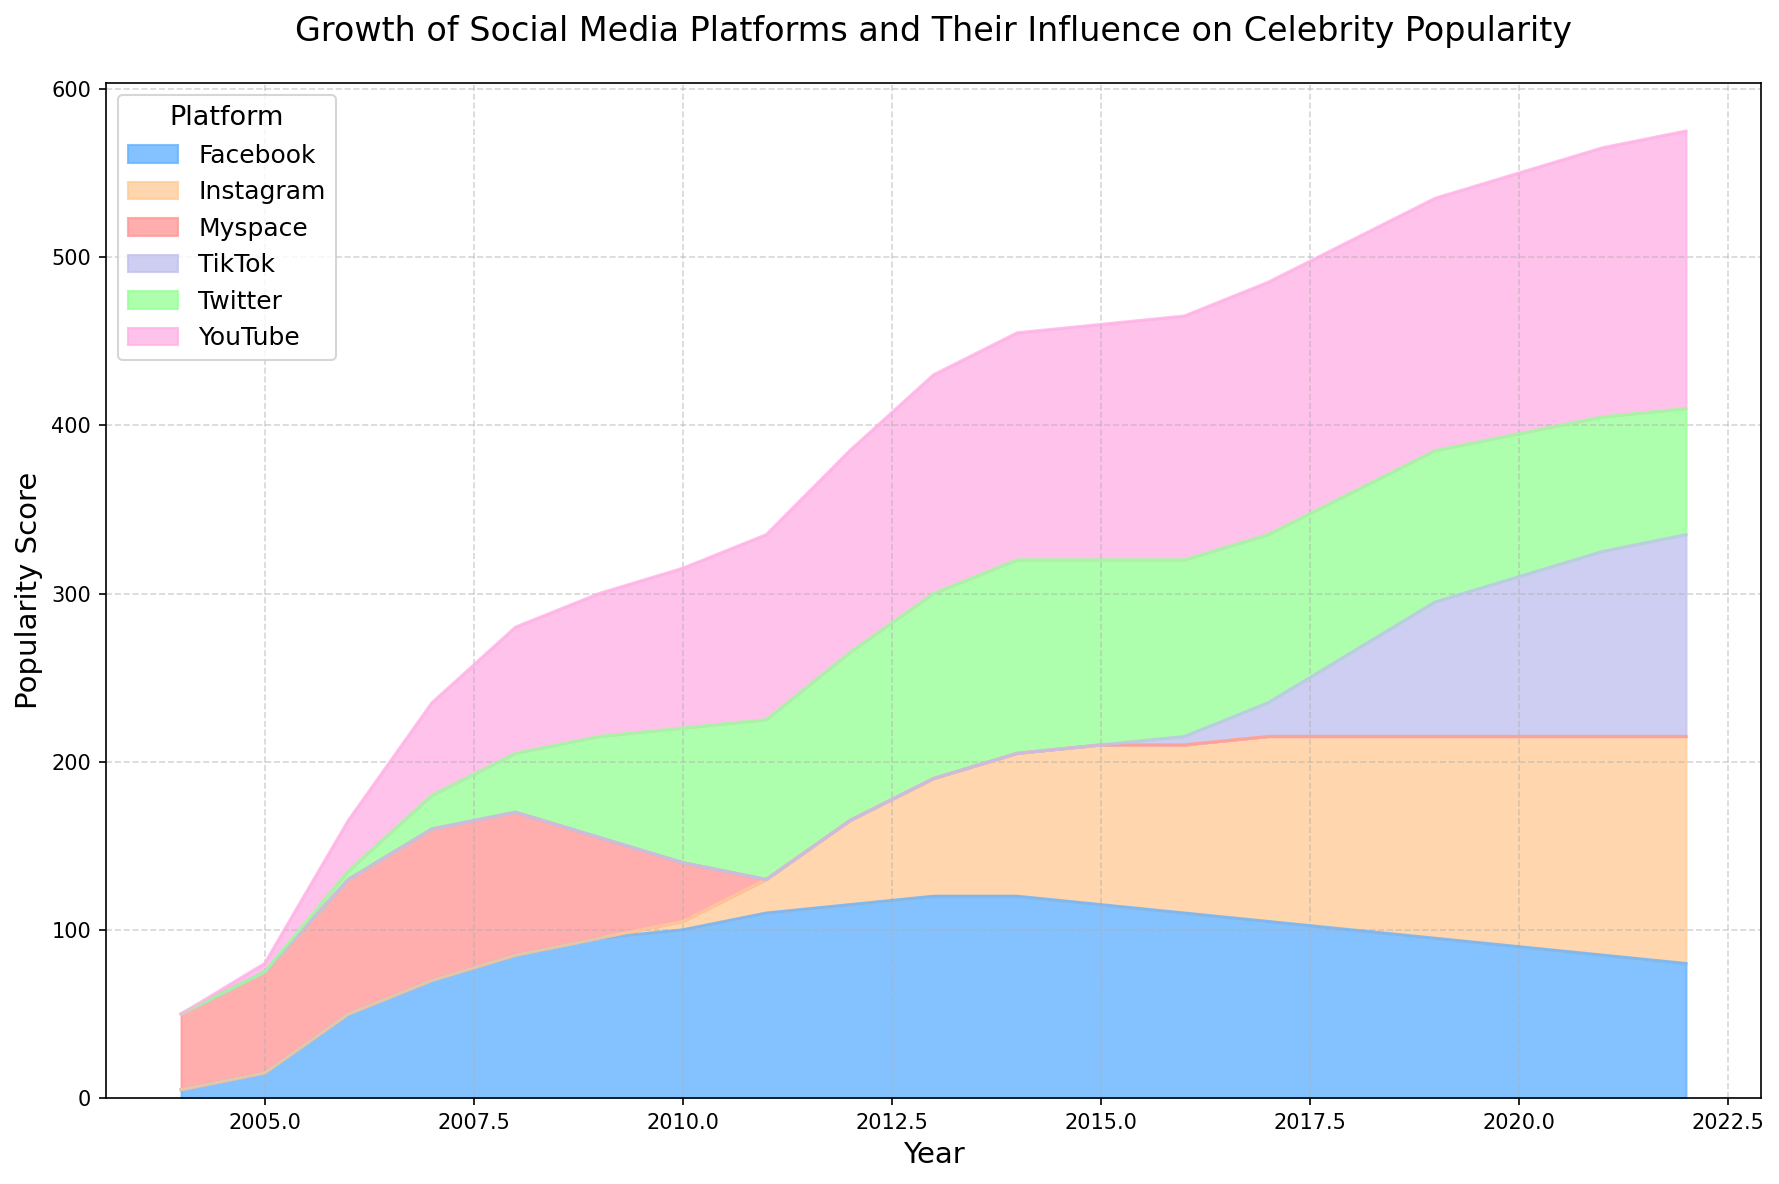What is the total popularity score for Instagram and Twitter in 2022? First, locate the year 2022 on the x-axis and identify the popularity scores for Instagram and Twitter. Instagram has a score of 135 and Twitter has 75. Sum these values: 135 + 75 = 210
Answer: 210 Which platform has shown the most consistent growth from its inception to 2022? Looking at the area chart, YouTube shows a steady and consistent growth trajectory from 2005 to 2022, without any significant dips or declines.
Answer: YouTube During which years did Myspace's popularity begin to decline and what is the initial score before the decline? Observe the plot for Myspace. Its popularity peaks in 2007 with a score of 90 and then begins to decline in 2008, lowering to 85 and continuing downward.
Answer: 2008, 90 Which platform surpassed Facebook in popularity first, Instagram or TikTok? Identify the year each platform exceeded Facebook's popularity. Instagram surpasses Facebook around 2019-2020. TikTok, although growing rapidly, does not surpass Facebook before 2022.
Answer: Instagram From the visual representation, which platform has the highest peak popularity score and what is that score? Observe the highest point on the y-axis for each platform. YouTube's peak reaches up to 165 in 2022, higher than any other platform.
Answer: YouTube, 165 Between which years did Facebook experience a decline in its popularity score? Inspect the trend line for Facebook. It experiences a decline from 2015 to 2022, where the score gradually decreases from 115 to 80.
Answer: 2015 to 2022 How did TikTok's popularity score change from 2018 to 2020? Locate the years 2018 and 2020 on the x-axis for TikTok. The score increases from 50 in 2018 to 95 in 2020.
Answer: Increased by 45 Which years did YouTube maintain the same popularity score? Inspect YouTube's trend. The platform maintains a score of 150 from 2017 to 2019 before increasing again.
Answer: 2017 to 2019 In 2010, which platform had the second-highest popularity score? Look at the year 2010 on the x-axis and compare the scores. YouTube has the highest at 95, and Facebook has the second-highest at 100.
Answer: Facebook 